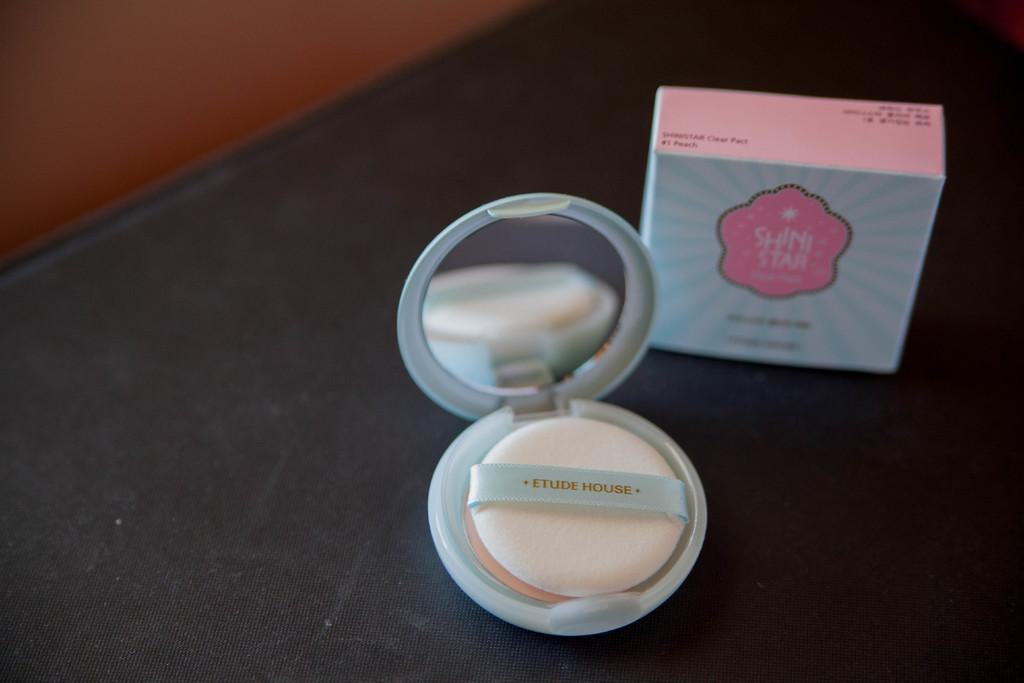<image>
Summarize the visual content of the image. A makeup kit is laying next to a box titled Shini Star. 